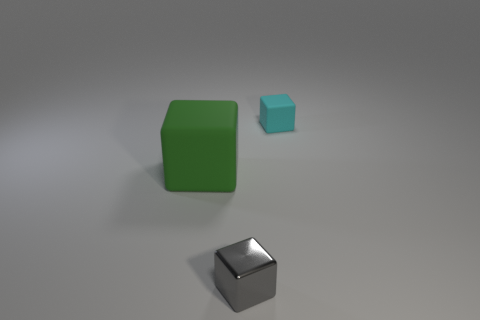How many objects are small matte blocks or big purple matte balls?
Your answer should be compact. 1. What shape is the gray metal object that is the same size as the cyan matte block?
Your answer should be compact. Cube. What number of blocks are both to the right of the big green thing and in front of the cyan thing?
Offer a terse response. 1. There is a small object to the right of the gray metallic cube; what is it made of?
Provide a succinct answer. Rubber. What size is the cyan thing that is the same material as the big green block?
Ensure brevity in your answer.  Small. There is a rubber object in front of the small cyan rubber thing; does it have the same size as the block that is right of the tiny metallic cube?
Keep it short and to the point. No. There is another thing that is the same size as the gray metallic thing; what material is it?
Provide a succinct answer. Rubber. The object that is both behind the small gray block and to the left of the tiny cyan block is made of what material?
Your answer should be very brief. Rubber. Are any gray things visible?
Provide a succinct answer. Yes. Does the small metallic object have the same color as the tiny block that is right of the small gray cube?
Your answer should be very brief. No. 